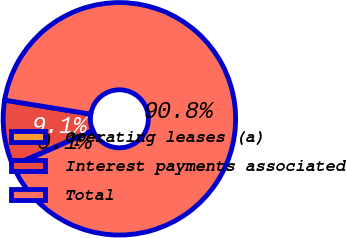Convert chart. <chart><loc_0><loc_0><loc_500><loc_500><pie_chart><fcel>Operating leases (a)<fcel>Interest payments associated<fcel>Total<nl><fcel>0.07%<fcel>9.14%<fcel>90.79%<nl></chart> 